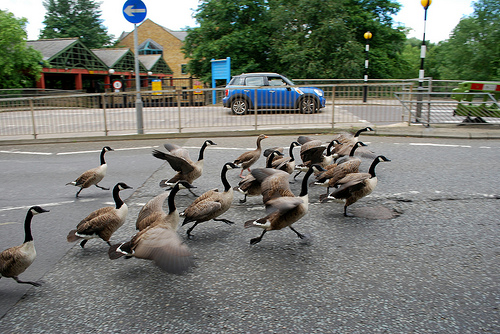<image>
Is there a car behind the ducks? Yes. From this viewpoint, the car is positioned behind the ducks, with the ducks partially or fully occluding the car. Is there a bird on the street? Yes. Looking at the image, I can see the bird is positioned on top of the street, with the street providing support. 